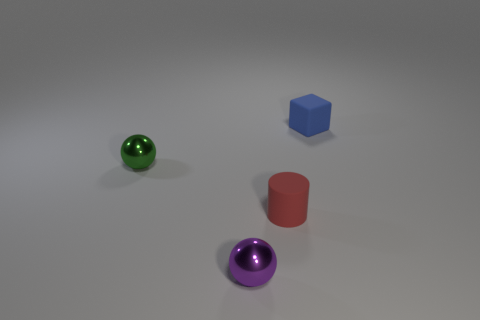Is the number of small shiny balls behind the small blue rubber thing greater than the number of tiny metal balls that are in front of the tiny purple sphere?
Your response must be concise. No. Are there more cylinders that are on the left side of the small blue thing than big cyan blocks?
Your answer should be very brief. Yes. Do the rubber cube and the cylinder have the same size?
Your answer should be very brief. Yes. What material is the green thing that is the same shape as the small purple thing?
Your answer should be very brief. Metal. Is there anything else that is made of the same material as the red cylinder?
Ensure brevity in your answer.  Yes. What number of red objects are tiny matte blocks or tiny matte cylinders?
Make the answer very short. 1. There is a thing on the left side of the purple shiny sphere; what material is it?
Keep it short and to the point. Metal. Is the number of yellow metal cylinders greater than the number of blue blocks?
Provide a short and direct response. No. There is a rubber thing that is in front of the tiny block; is its shape the same as the purple metallic object?
Offer a terse response. No. What number of things are in front of the blue matte object and right of the small purple metallic thing?
Offer a very short reply. 1. 